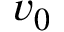Convert formula to latex. <formula><loc_0><loc_0><loc_500><loc_500>v _ { 0 }</formula> 